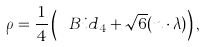Convert formula to latex. <formula><loc_0><loc_0><loc_500><loc_500>\rho = \frac { 1 } { 4 } \left ( \ B i d _ { 4 } + \sqrt { 6 } ( n \cdot \lambda ) \right ) ,</formula> 